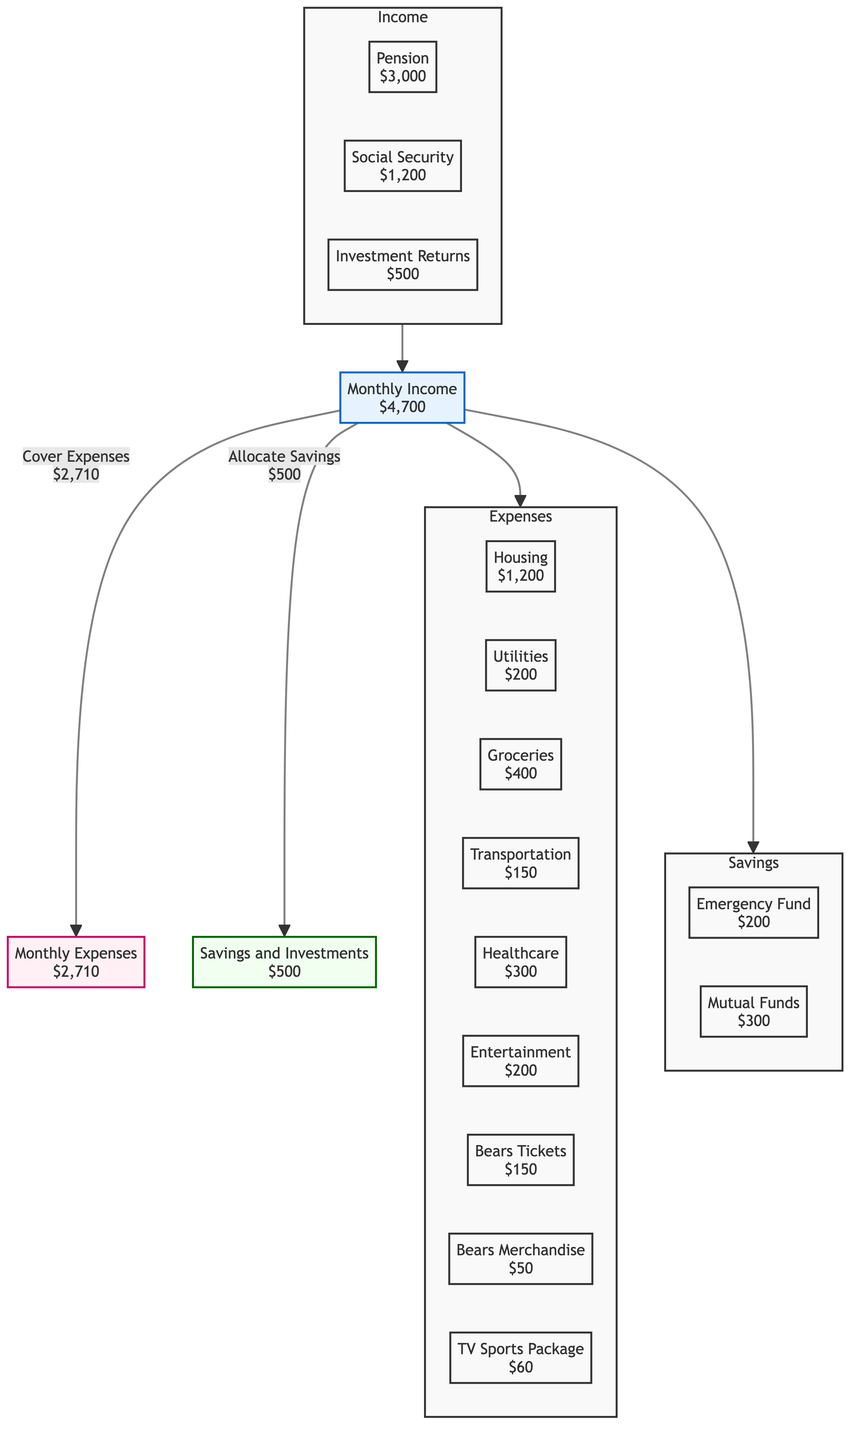What is the total monthly income? The diagram shows three sources of income: Pension ($3,000), Social Security ($1,200), and Investment Returns ($500). Adding these amounts gives $3,000 + $1,200 + $500 = $4,700.
Answer: $4,700 How much is allocated to entertainment expenses? The diagram indicates that entertainment expenses cost $200 and shows a direct link from the expenses node to this specific category.
Answer: $200 What is the amount saved in the emergency fund? The savings subgraph lists the emergency fund, which specifies $200 set aside. Thus, the amount saved in this fund is $200.
Answer: $200 How much is spent on Bears tickets? The diagram shows a specific expense category for Bears Tickets, which is marked as $150. This directly indicates the expenditure amount for this item.
Answer: $150 What is the total amount allocated to savings and investments? The savings and investments split into two parts: Emergency Fund ($200) and Mutual Funds ($300), when combined these equal $200 + $300 = $500 allocated towards savings and investments.
Answer: $500 What percentage of income is spent on housing? Housing expenses are $1,200, and the total monthly income is $4,700. To find the percentage, divide $1,200 by $4,700 and multiply by 100, yielding approximately 25.53%.
Answer: Approximately 25.53% How many expense categories are shown in the diagram? The expenses subgraph includes eight specific categories: Housing, Utilities, Groceries, Transportation, Healthcare, Entertainment, Football Tickets, Merchandise, and Subscription. Counting these categories gives a total of eight.
Answer: 8 What is the total monthly expenditure? There is a direct node indicating monthly expenses of $2,710 that includes all the specific expenses listed in the expenses subgraph. This value serves as the total for monthly expenditure.
Answer: $2,710 How much is allocated to investment returns as part of income? The diagram specifies a node for Investment Returns, which is listed as $500. This figure directly shows the amount allocated to investment returns.
Answer: $500 